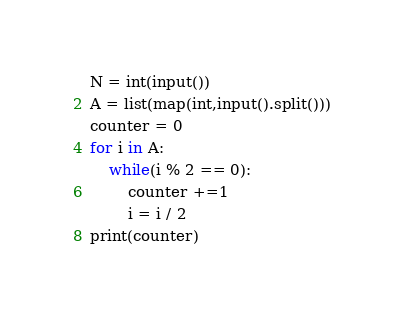<code> <loc_0><loc_0><loc_500><loc_500><_Python_>N = int(input())
A = list(map(int,input().split()))
counter = 0
for i in A:
    while(i % 2 == 0):
        counter +=1
        i = i / 2
print(counter)</code> 